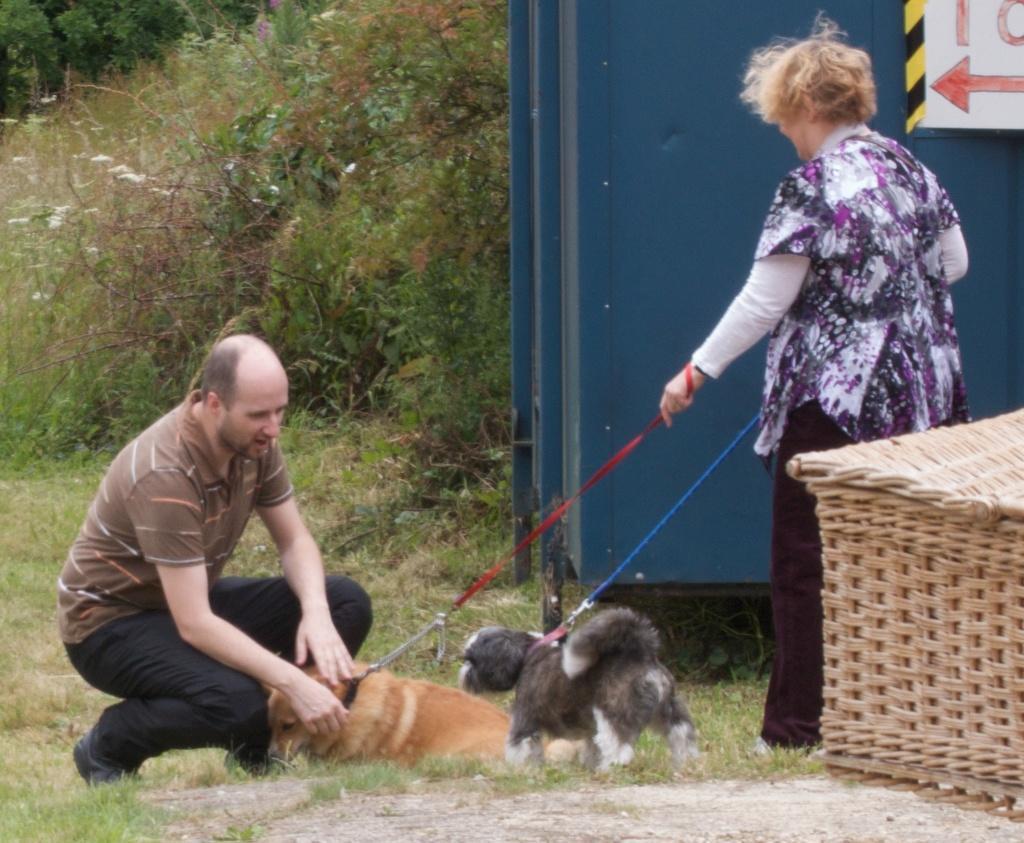Please provide a concise description of this image. In this image i can see a woman standing wearing a pink and black dress holding two dos belt, at left there is other man standing wearing a brown shirt and black pant, there are two dogs laying at right there is a basket, at the back ground i can see a board in blue color and trees. 